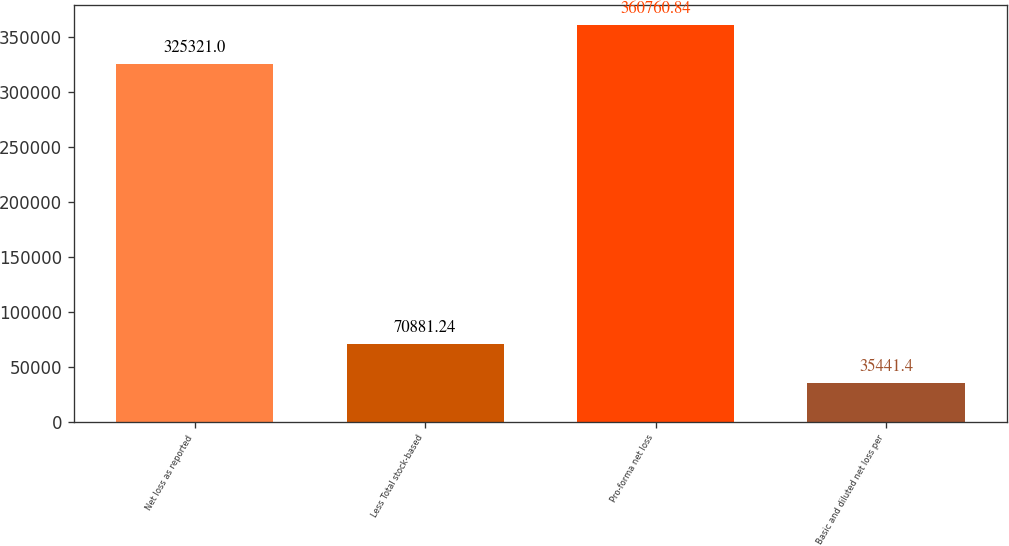<chart> <loc_0><loc_0><loc_500><loc_500><bar_chart><fcel>Net loss as reported<fcel>Less Total stock-based<fcel>Pro-forma net loss<fcel>Basic and diluted net loss per<nl><fcel>325321<fcel>70881.2<fcel>360761<fcel>35441.4<nl></chart> 